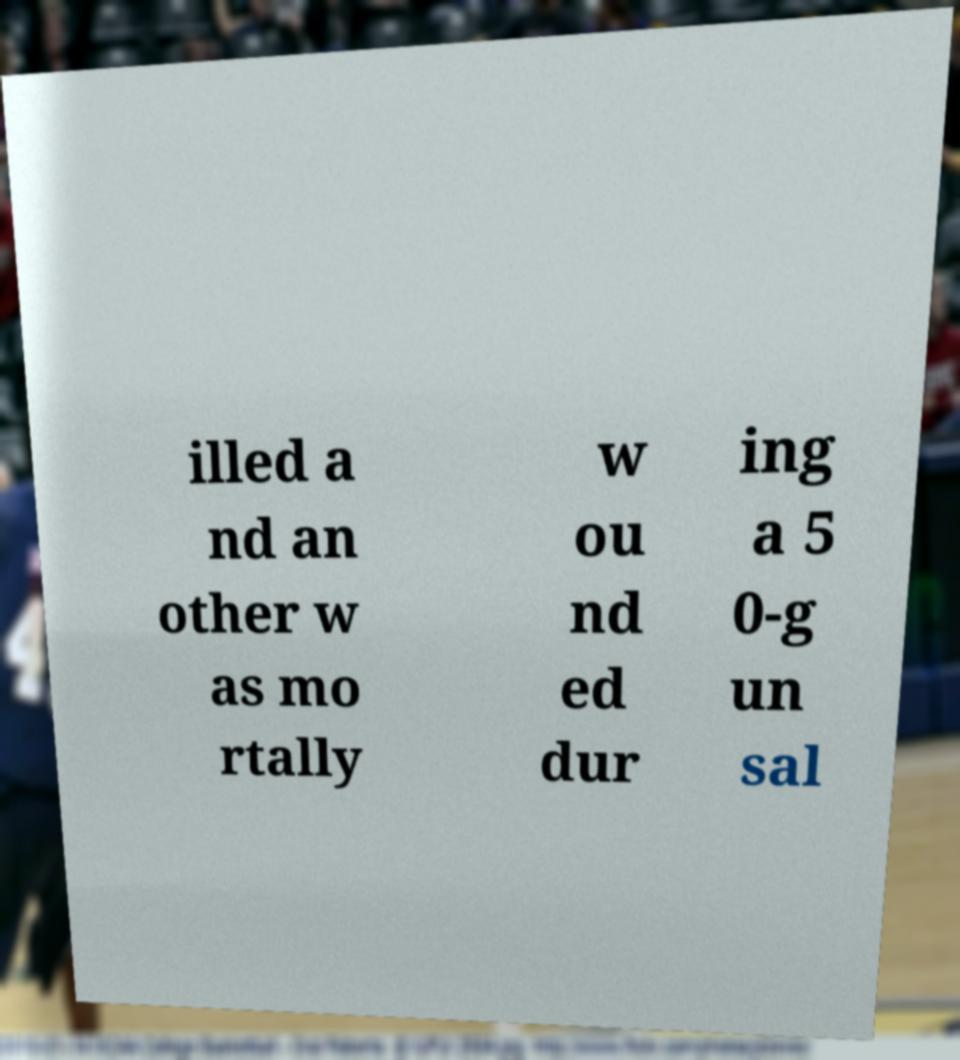What messages or text are displayed in this image? I need them in a readable, typed format. illed a nd an other w as mo rtally w ou nd ed dur ing a 5 0-g un sal 